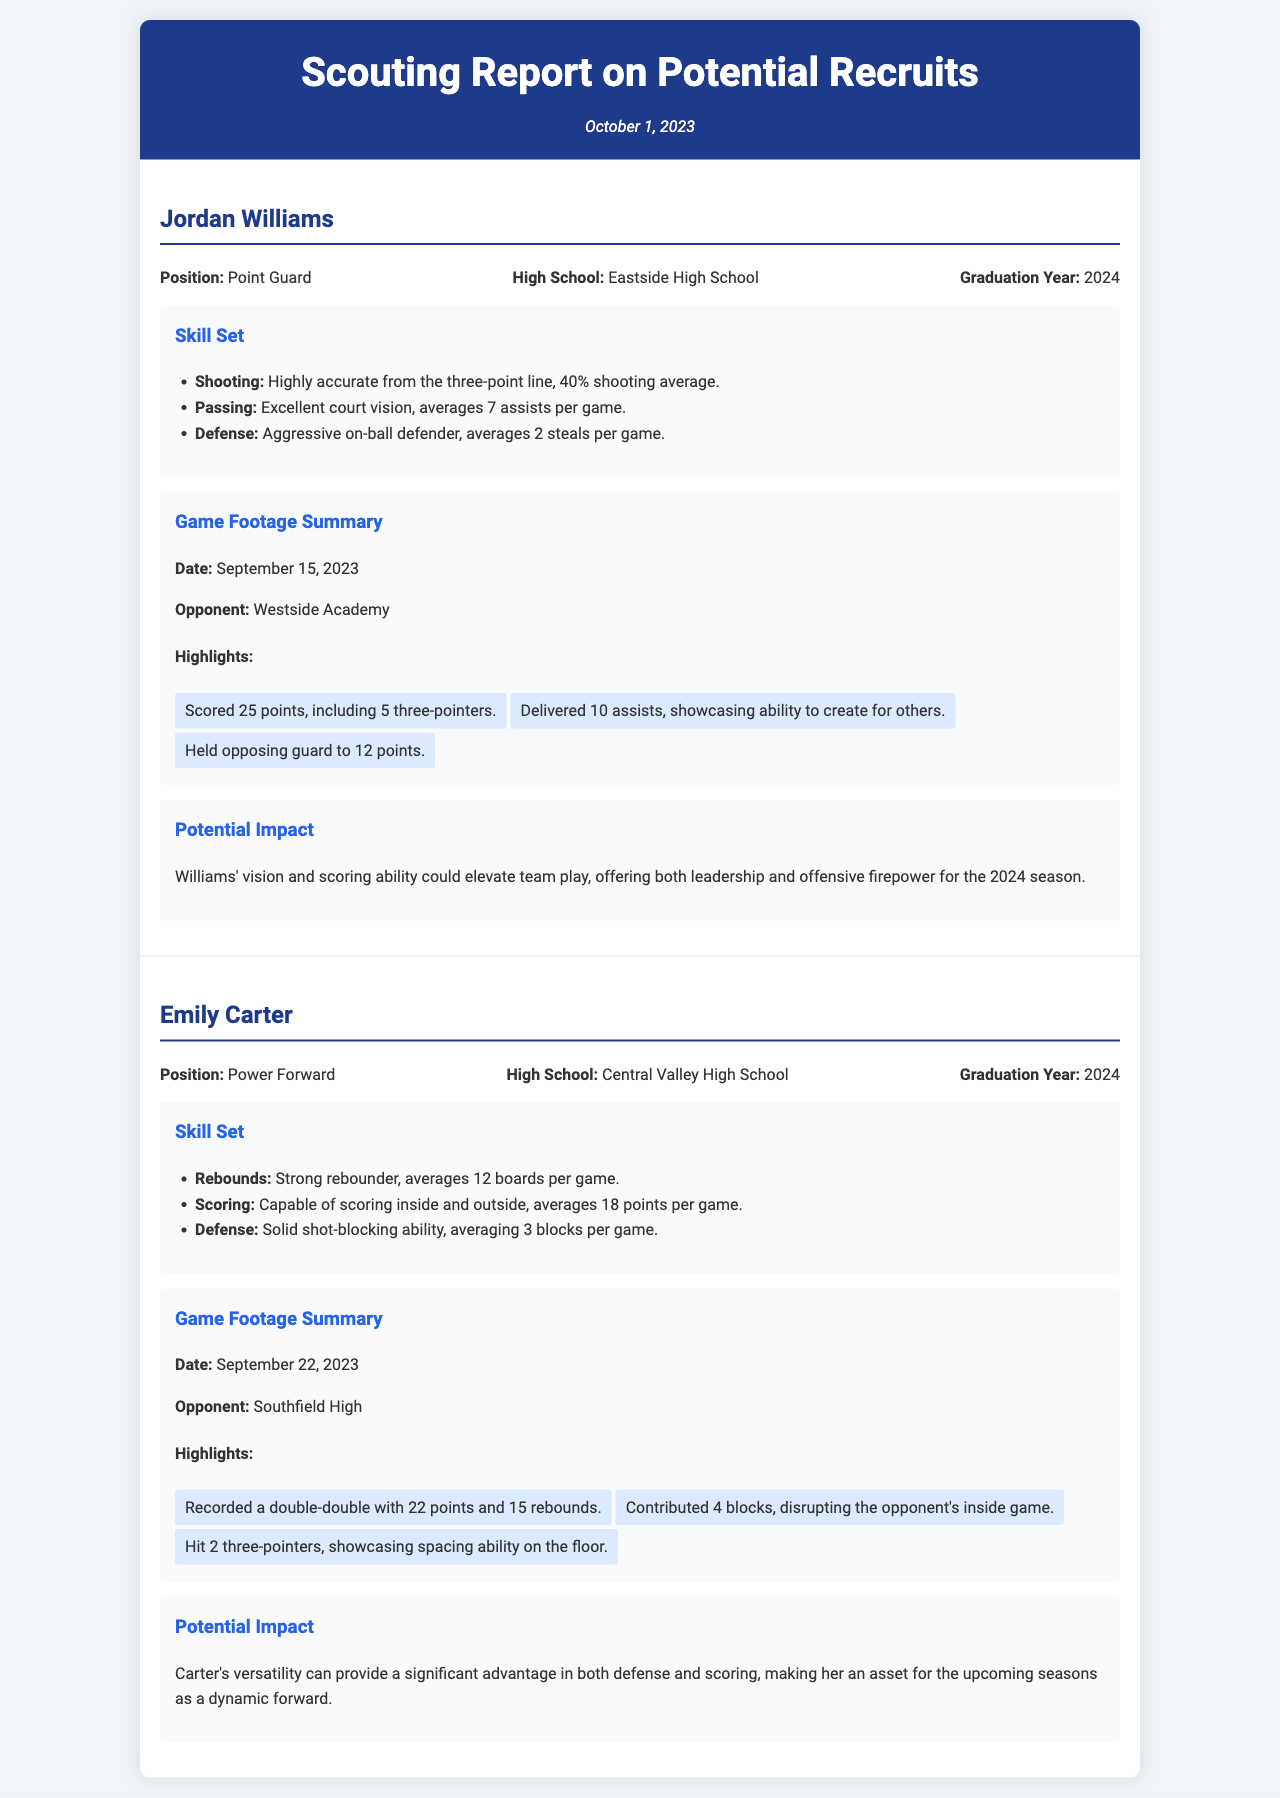What is the name of the first recruit? The first recruit mentioned in the report is Jordan Williams.
Answer: Jordan Williams What position does Emily Carter play? Emily Carter is identified as a Power Forward in the document.
Answer: Power Forward What is Jordan Williams' shooting average from the three-point line? The document states that Jordan Williams has a 40% shooting average from the three-point line.
Answer: 40% How many assists per game does Jordan Williams average? The report indicates that Jordan Williams averages 7 assists per game.
Answer: 7 assists What significant achievement did Emily Carter have against Southfield High? The report highlights that Emily Carter recorded a double-double with 22 points and 15 rebounds.
Answer: 22 points and 15 rebounds How many steals per game does Jordan Williams average? The document mentions that he averages 2 steals per game.
Answer: 2 steals What date was the game footage for Jordan Williams recorded? The game footage summary states that it was recorded on September 15, 2023.
Answer: September 15, 2023 What aspect of Emily Carter's game is highlighted in her scoring? The report notes her ability to score both inside and outside, averaging 18 points per game.
Answer: Inside and outside What is the overall potential impact of Jordan Williams on the team? The document describes his vision and scoring ability as elevating team play with leadership.
Answer: Leadership and offensive firepower 